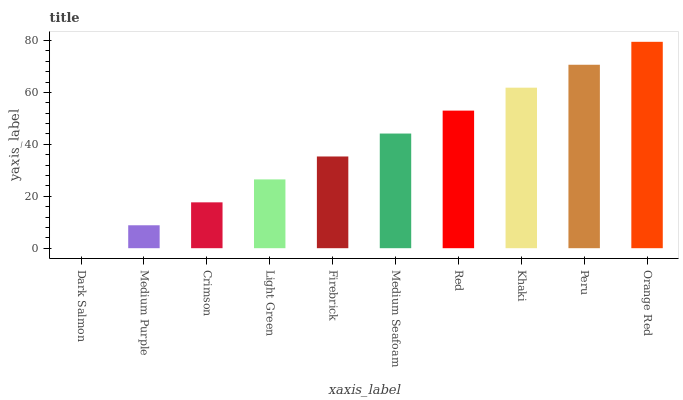Is Dark Salmon the minimum?
Answer yes or no. Yes. Is Orange Red the maximum?
Answer yes or no. Yes. Is Medium Purple the minimum?
Answer yes or no. No. Is Medium Purple the maximum?
Answer yes or no. No. Is Medium Purple greater than Dark Salmon?
Answer yes or no. Yes. Is Dark Salmon less than Medium Purple?
Answer yes or no. Yes. Is Dark Salmon greater than Medium Purple?
Answer yes or no. No. Is Medium Purple less than Dark Salmon?
Answer yes or no. No. Is Medium Seafoam the high median?
Answer yes or no. Yes. Is Firebrick the low median?
Answer yes or no. Yes. Is Red the high median?
Answer yes or no. No. Is Khaki the low median?
Answer yes or no. No. 